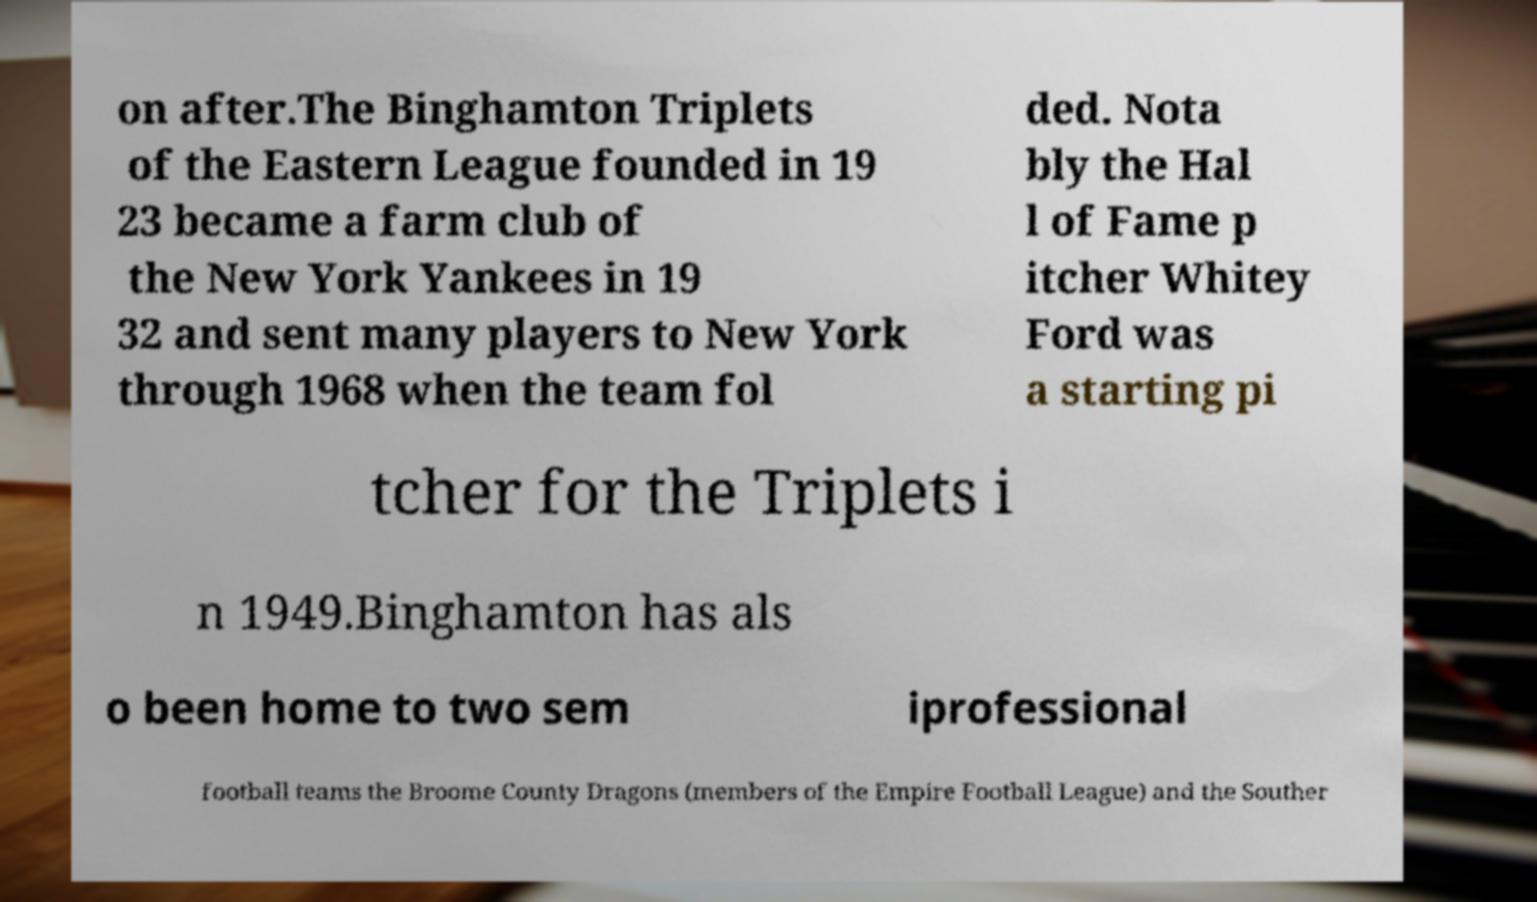Can you read and provide the text displayed in the image?This photo seems to have some interesting text. Can you extract and type it out for me? on after.The Binghamton Triplets of the Eastern League founded in 19 23 became a farm club of the New York Yankees in 19 32 and sent many players to New York through 1968 when the team fol ded. Nota bly the Hal l of Fame p itcher Whitey Ford was a starting pi tcher for the Triplets i n 1949.Binghamton has als o been home to two sem iprofessional football teams the Broome County Dragons (members of the Empire Football League) and the Souther 